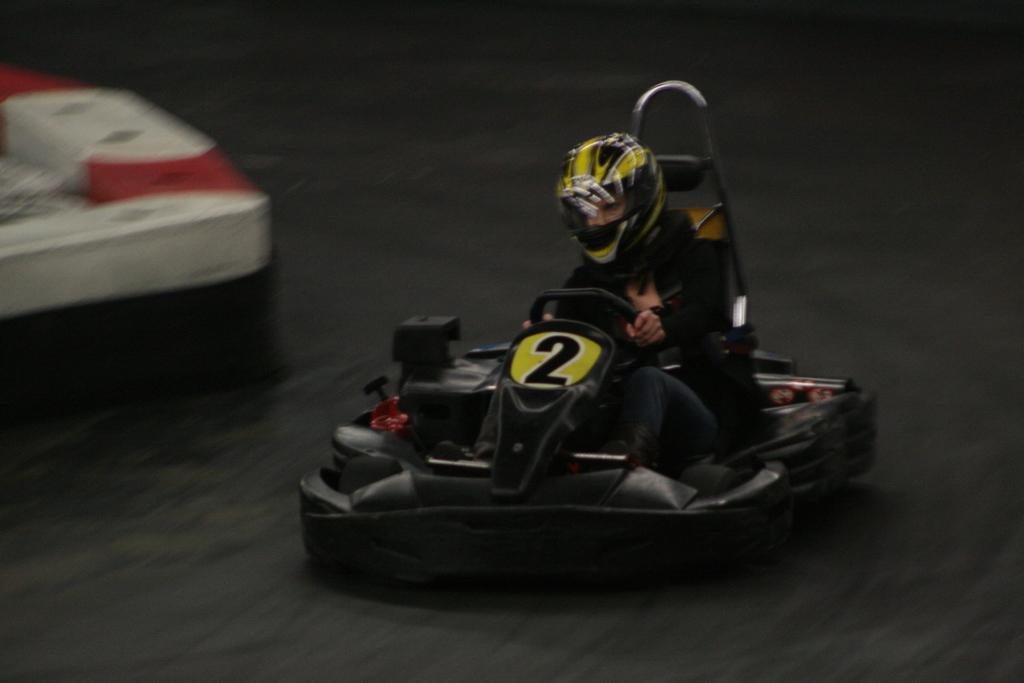How would you summarize this image in a sentence or two? In this image I can see a person wearing a helmet to the head and driving a go-kart. On the left side there is a white color object. 